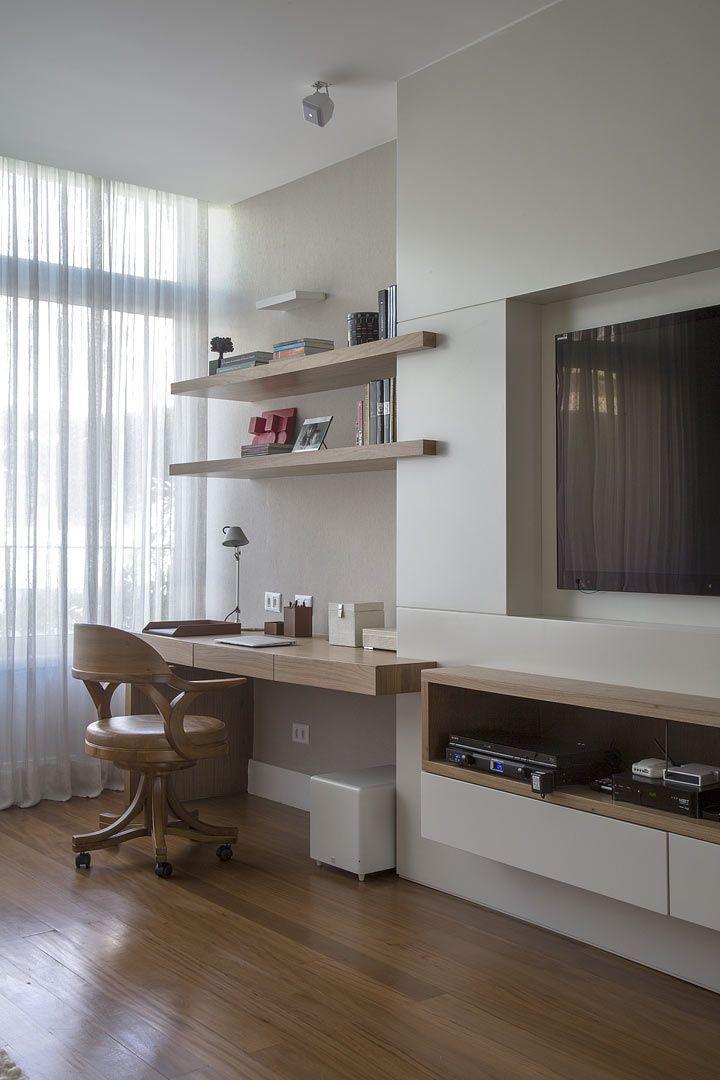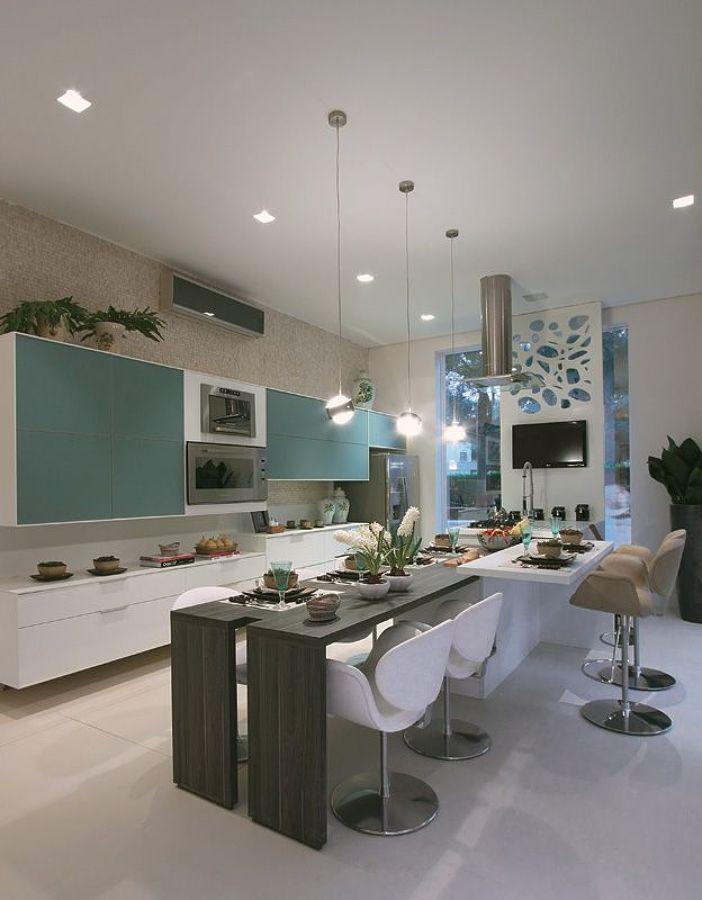The first image is the image on the left, the second image is the image on the right. For the images shown, is this caption "There is at least one light dangling from the ceiling." true? Answer yes or no. Yes. The first image is the image on the left, the second image is the image on the right. Examine the images to the left and right. Is the description "Curtains cover a window in the image on the left." accurate? Answer yes or no. Yes. 